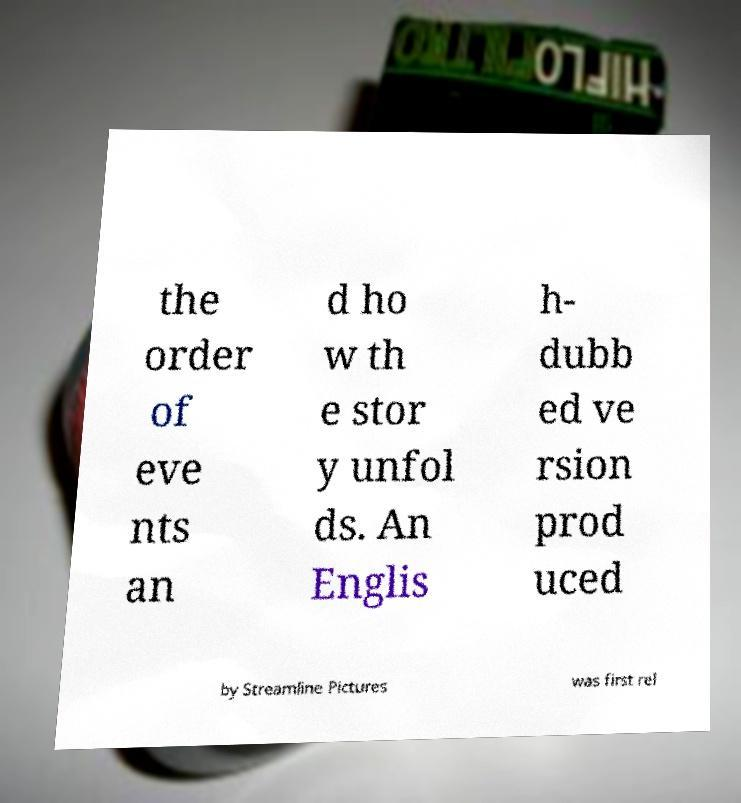I need the written content from this picture converted into text. Can you do that? the order of eve nts an d ho w th e stor y unfol ds. An Englis h- dubb ed ve rsion prod uced by Streamline Pictures was first rel 